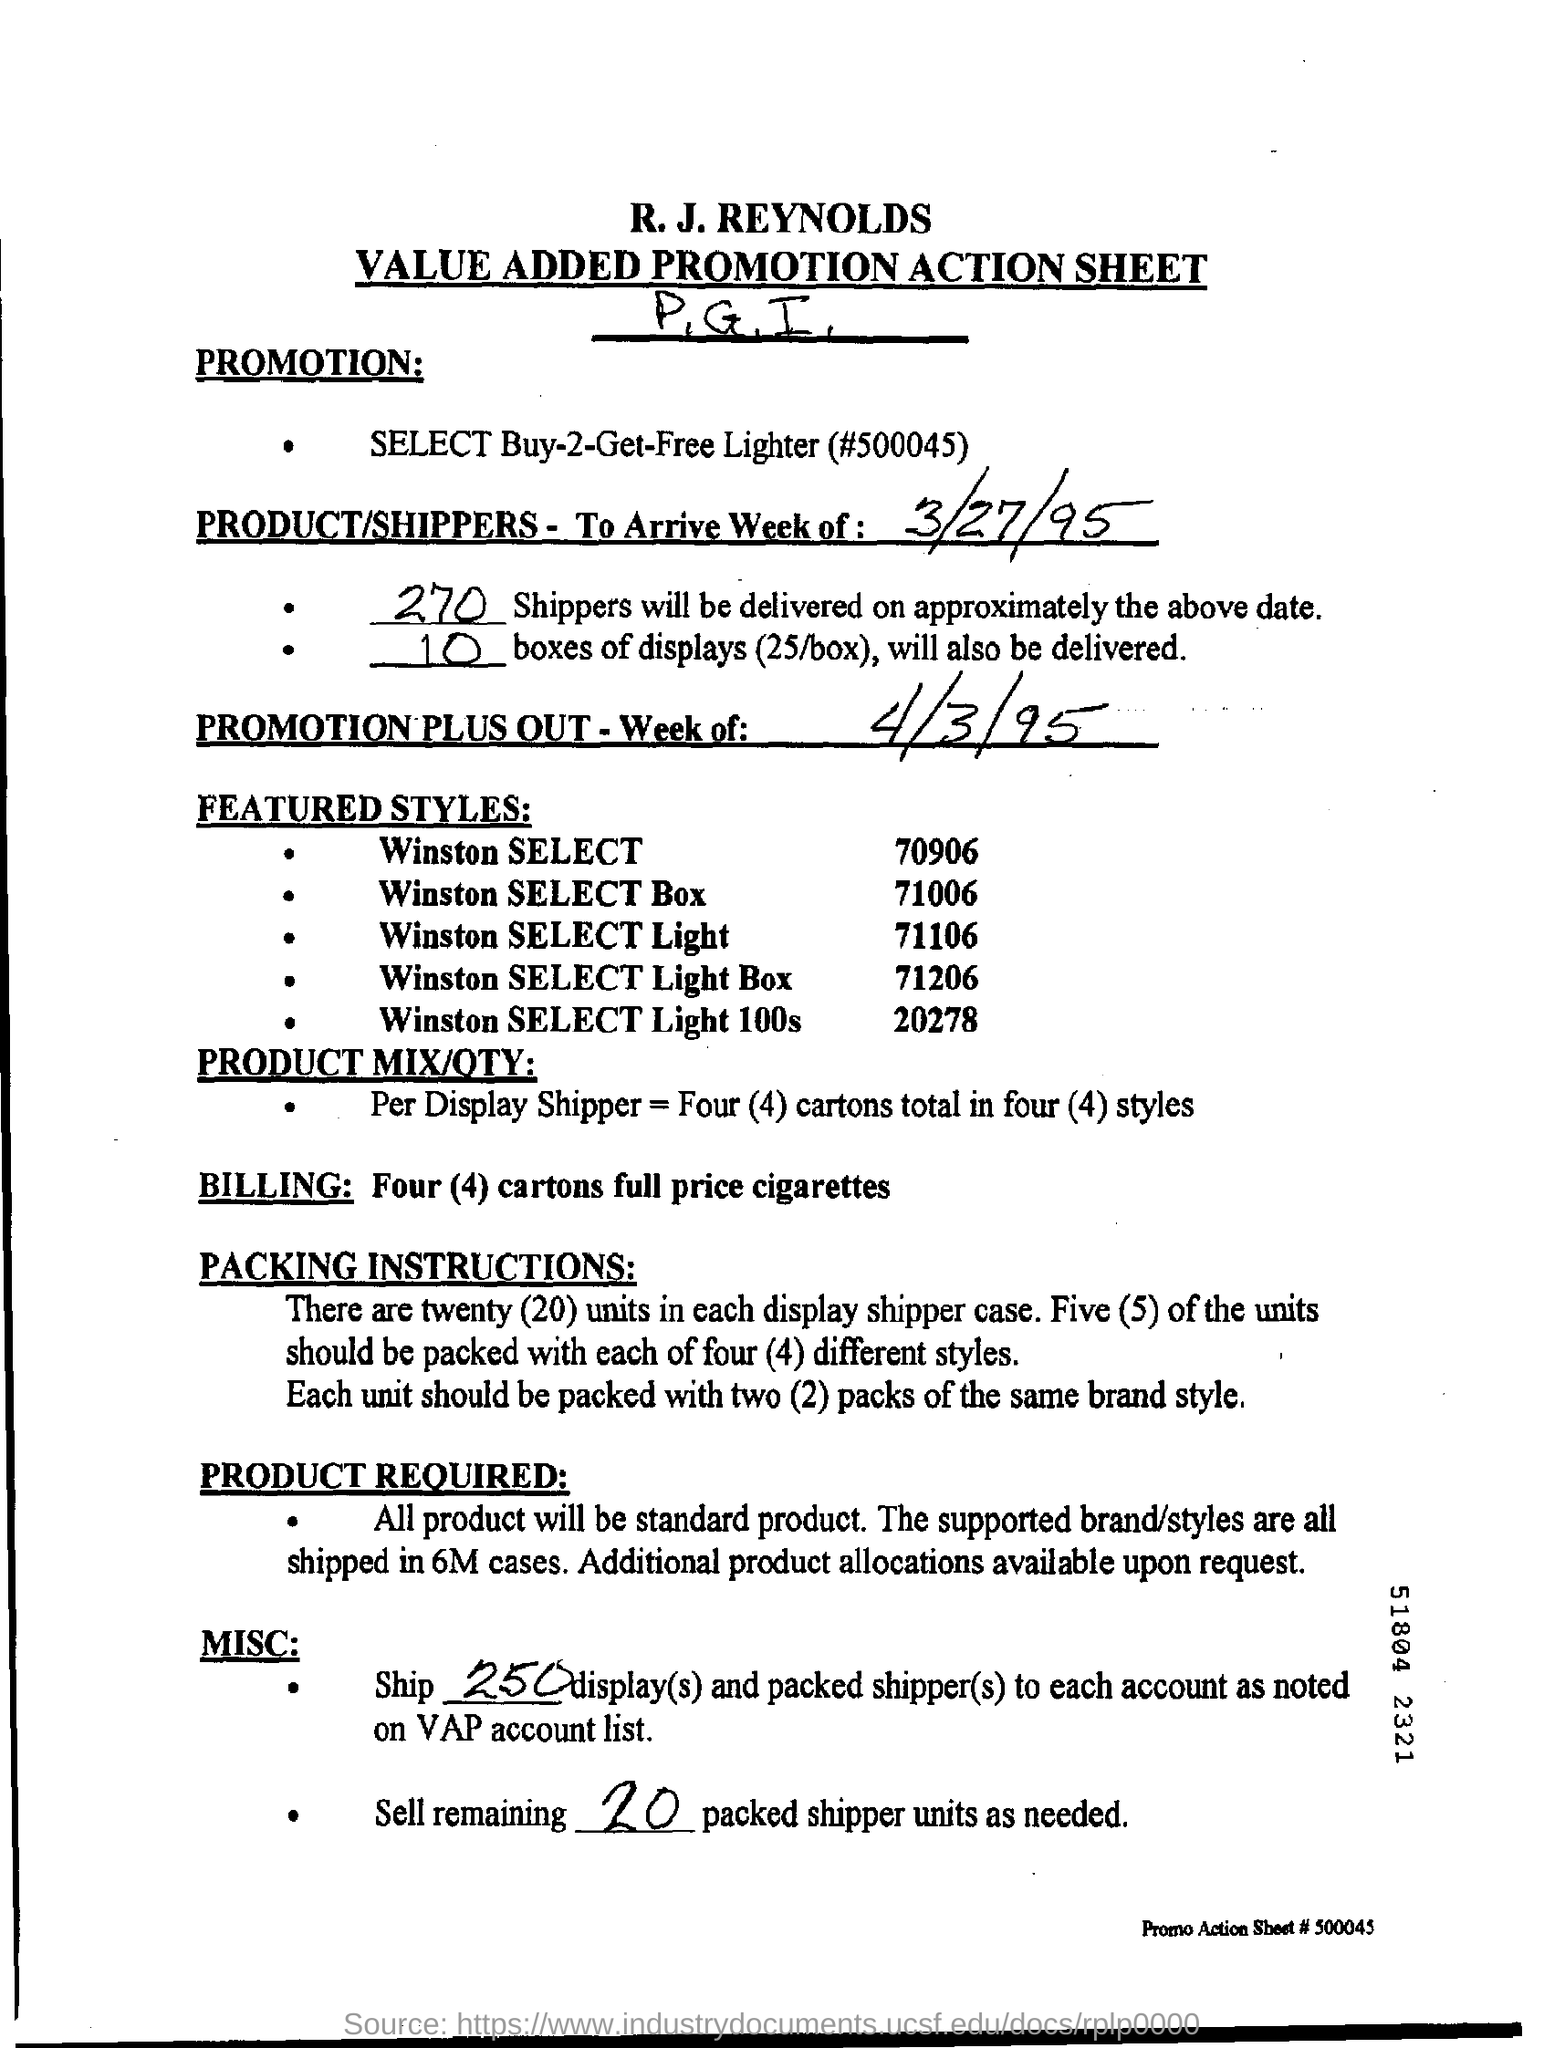Identify some key points in this picture. The first title in the document is 'R.J.Reynolds.' This document contains a title that is the second in its sequence, which is 'Value Added Promotion Action Sheet.' 